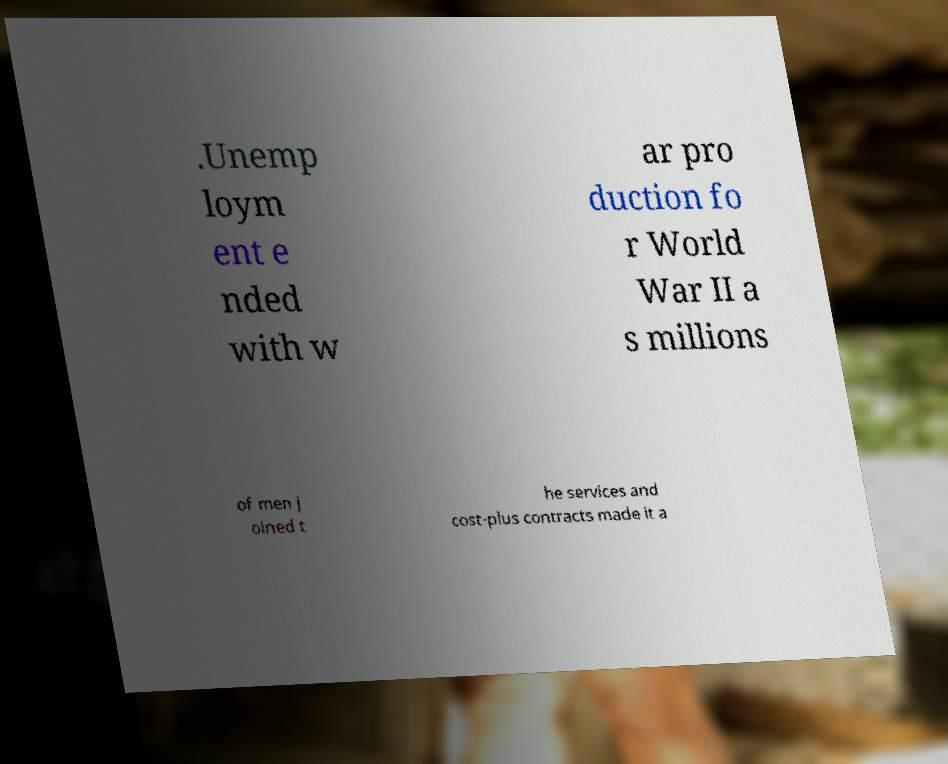For documentation purposes, I need the text within this image transcribed. Could you provide that? .Unemp loym ent e nded with w ar pro duction fo r World War II a s millions of men j oined t he services and cost-plus contracts made it a 